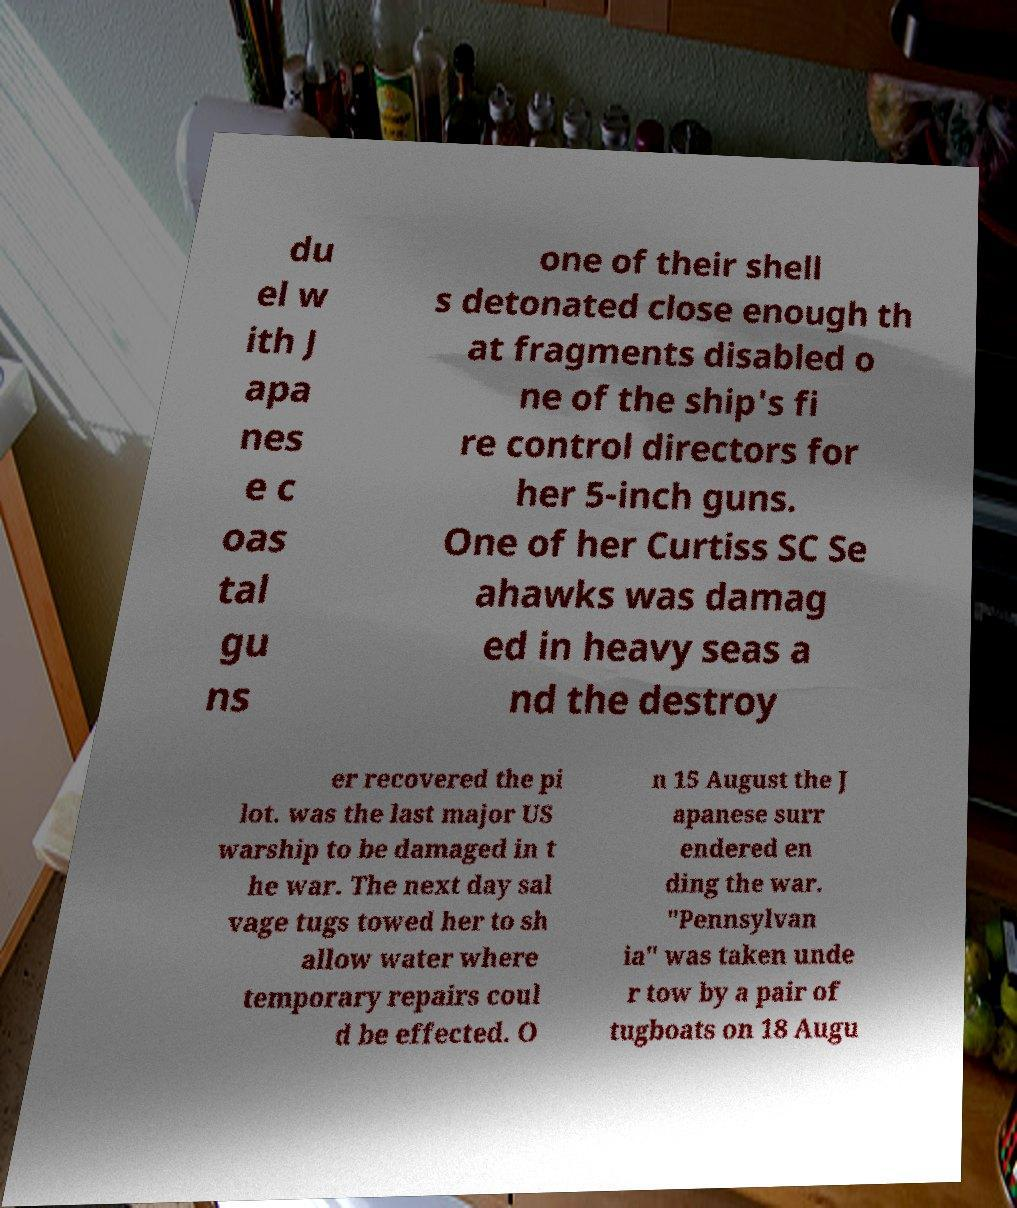Can you accurately transcribe the text from the provided image for me? du el w ith J apa nes e c oas tal gu ns one of their shell s detonated close enough th at fragments disabled o ne of the ship's fi re control directors for her 5-inch guns. One of her Curtiss SC Se ahawks was damag ed in heavy seas a nd the destroy er recovered the pi lot. was the last major US warship to be damaged in t he war. The next day sal vage tugs towed her to sh allow water where temporary repairs coul d be effected. O n 15 August the J apanese surr endered en ding the war. "Pennsylvan ia" was taken unde r tow by a pair of tugboats on 18 Augu 